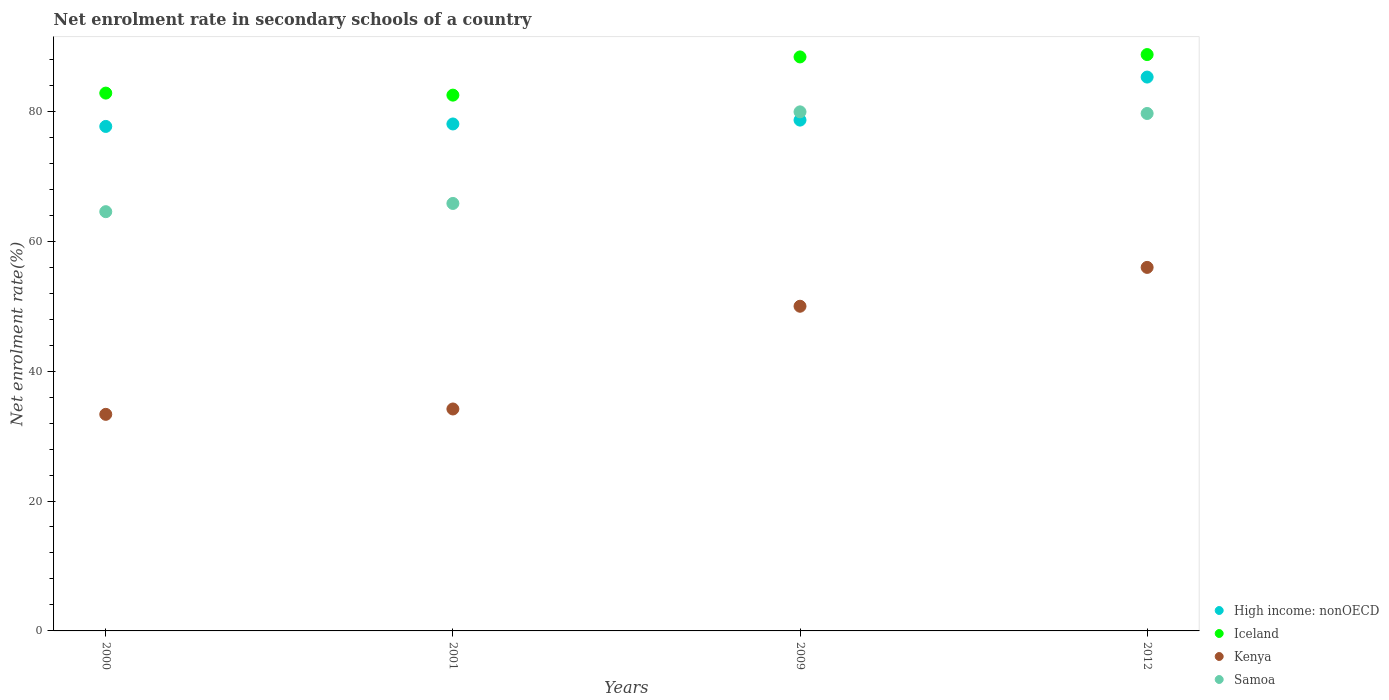What is the net enrolment rate in secondary schools in Iceland in 2000?
Provide a short and direct response. 82.8. Across all years, what is the maximum net enrolment rate in secondary schools in High income: nonOECD?
Make the answer very short. 85.27. Across all years, what is the minimum net enrolment rate in secondary schools in Iceland?
Your answer should be compact. 82.49. What is the total net enrolment rate in secondary schools in Kenya in the graph?
Your answer should be very brief. 173.46. What is the difference between the net enrolment rate in secondary schools in High income: nonOECD in 2009 and that in 2012?
Ensure brevity in your answer.  -6.63. What is the difference between the net enrolment rate in secondary schools in Iceland in 2000 and the net enrolment rate in secondary schools in Samoa in 2012?
Make the answer very short. 3.14. What is the average net enrolment rate in secondary schools in Kenya per year?
Offer a very short reply. 43.37. In the year 2009, what is the difference between the net enrolment rate in secondary schools in High income: nonOECD and net enrolment rate in secondary schools in Kenya?
Provide a short and direct response. 28.66. In how many years, is the net enrolment rate in secondary schools in Iceland greater than 48 %?
Keep it short and to the point. 4. What is the ratio of the net enrolment rate in secondary schools in High income: nonOECD in 2000 to that in 2012?
Your response must be concise. 0.91. Is the difference between the net enrolment rate in secondary schools in High income: nonOECD in 2001 and 2009 greater than the difference between the net enrolment rate in secondary schools in Kenya in 2001 and 2009?
Offer a terse response. Yes. What is the difference between the highest and the second highest net enrolment rate in secondary schools in High income: nonOECD?
Keep it short and to the point. 6.63. What is the difference between the highest and the lowest net enrolment rate in secondary schools in High income: nonOECD?
Provide a succinct answer. 7.6. Is it the case that in every year, the sum of the net enrolment rate in secondary schools in High income: nonOECD and net enrolment rate in secondary schools in Kenya  is greater than the sum of net enrolment rate in secondary schools in Samoa and net enrolment rate in secondary schools in Iceland?
Provide a succinct answer. Yes. Is it the case that in every year, the sum of the net enrolment rate in secondary schools in Samoa and net enrolment rate in secondary schools in Kenya  is greater than the net enrolment rate in secondary schools in Iceland?
Provide a short and direct response. Yes. Does the net enrolment rate in secondary schools in High income: nonOECD monotonically increase over the years?
Provide a succinct answer. Yes. Is the net enrolment rate in secondary schools in Iceland strictly greater than the net enrolment rate in secondary schools in High income: nonOECD over the years?
Offer a terse response. Yes. Is the net enrolment rate in secondary schools in Samoa strictly less than the net enrolment rate in secondary schools in Kenya over the years?
Your answer should be compact. No. How many dotlines are there?
Your answer should be compact. 4. How many years are there in the graph?
Your answer should be compact. 4. Does the graph contain any zero values?
Your response must be concise. No. Where does the legend appear in the graph?
Your answer should be compact. Bottom right. How many legend labels are there?
Keep it short and to the point. 4. What is the title of the graph?
Your answer should be very brief. Net enrolment rate in secondary schools of a country. Does "Belarus" appear as one of the legend labels in the graph?
Your answer should be compact. No. What is the label or title of the X-axis?
Offer a terse response. Years. What is the label or title of the Y-axis?
Offer a very short reply. Net enrolment rate(%). What is the Net enrolment rate(%) in High income: nonOECD in 2000?
Offer a very short reply. 77.67. What is the Net enrolment rate(%) in Iceland in 2000?
Your response must be concise. 82.8. What is the Net enrolment rate(%) of Kenya in 2000?
Ensure brevity in your answer.  33.34. What is the Net enrolment rate(%) in Samoa in 2000?
Keep it short and to the point. 64.54. What is the Net enrolment rate(%) of High income: nonOECD in 2001?
Offer a terse response. 78.05. What is the Net enrolment rate(%) in Iceland in 2001?
Ensure brevity in your answer.  82.49. What is the Net enrolment rate(%) of Kenya in 2001?
Offer a terse response. 34.17. What is the Net enrolment rate(%) of Samoa in 2001?
Your answer should be compact. 65.81. What is the Net enrolment rate(%) in High income: nonOECD in 2009?
Keep it short and to the point. 78.64. What is the Net enrolment rate(%) of Iceland in 2009?
Provide a short and direct response. 88.37. What is the Net enrolment rate(%) of Kenya in 2009?
Your answer should be compact. 49.98. What is the Net enrolment rate(%) of Samoa in 2009?
Provide a short and direct response. 79.91. What is the Net enrolment rate(%) in High income: nonOECD in 2012?
Provide a succinct answer. 85.27. What is the Net enrolment rate(%) of Iceland in 2012?
Ensure brevity in your answer.  88.73. What is the Net enrolment rate(%) of Kenya in 2012?
Provide a short and direct response. 55.97. What is the Net enrolment rate(%) of Samoa in 2012?
Ensure brevity in your answer.  79.66. Across all years, what is the maximum Net enrolment rate(%) in High income: nonOECD?
Make the answer very short. 85.27. Across all years, what is the maximum Net enrolment rate(%) of Iceland?
Offer a very short reply. 88.73. Across all years, what is the maximum Net enrolment rate(%) in Kenya?
Offer a terse response. 55.97. Across all years, what is the maximum Net enrolment rate(%) of Samoa?
Your response must be concise. 79.91. Across all years, what is the minimum Net enrolment rate(%) in High income: nonOECD?
Keep it short and to the point. 77.67. Across all years, what is the minimum Net enrolment rate(%) of Iceland?
Provide a succinct answer. 82.49. Across all years, what is the minimum Net enrolment rate(%) in Kenya?
Give a very brief answer. 33.34. Across all years, what is the minimum Net enrolment rate(%) of Samoa?
Make the answer very short. 64.54. What is the total Net enrolment rate(%) of High income: nonOECD in the graph?
Provide a succinct answer. 319.62. What is the total Net enrolment rate(%) of Iceland in the graph?
Give a very brief answer. 342.38. What is the total Net enrolment rate(%) of Kenya in the graph?
Provide a succinct answer. 173.46. What is the total Net enrolment rate(%) in Samoa in the graph?
Make the answer very short. 289.93. What is the difference between the Net enrolment rate(%) in High income: nonOECD in 2000 and that in 2001?
Provide a succinct answer. -0.38. What is the difference between the Net enrolment rate(%) in Iceland in 2000 and that in 2001?
Your answer should be compact. 0.31. What is the difference between the Net enrolment rate(%) in Kenya in 2000 and that in 2001?
Offer a very short reply. -0.83. What is the difference between the Net enrolment rate(%) in Samoa in 2000 and that in 2001?
Provide a short and direct response. -1.27. What is the difference between the Net enrolment rate(%) of High income: nonOECD in 2000 and that in 2009?
Your answer should be very brief. -0.97. What is the difference between the Net enrolment rate(%) of Iceland in 2000 and that in 2009?
Make the answer very short. -5.57. What is the difference between the Net enrolment rate(%) in Kenya in 2000 and that in 2009?
Your answer should be very brief. -16.64. What is the difference between the Net enrolment rate(%) of Samoa in 2000 and that in 2009?
Your response must be concise. -15.37. What is the difference between the Net enrolment rate(%) of High income: nonOECD in 2000 and that in 2012?
Make the answer very short. -7.6. What is the difference between the Net enrolment rate(%) of Iceland in 2000 and that in 2012?
Make the answer very short. -5.93. What is the difference between the Net enrolment rate(%) of Kenya in 2000 and that in 2012?
Your answer should be very brief. -22.62. What is the difference between the Net enrolment rate(%) of Samoa in 2000 and that in 2012?
Provide a short and direct response. -15.12. What is the difference between the Net enrolment rate(%) of High income: nonOECD in 2001 and that in 2009?
Your answer should be compact. -0.59. What is the difference between the Net enrolment rate(%) in Iceland in 2001 and that in 2009?
Provide a succinct answer. -5.88. What is the difference between the Net enrolment rate(%) of Kenya in 2001 and that in 2009?
Provide a short and direct response. -15.82. What is the difference between the Net enrolment rate(%) in Samoa in 2001 and that in 2009?
Offer a very short reply. -14.1. What is the difference between the Net enrolment rate(%) in High income: nonOECD in 2001 and that in 2012?
Provide a short and direct response. -7.22. What is the difference between the Net enrolment rate(%) of Iceland in 2001 and that in 2012?
Your answer should be very brief. -6.25. What is the difference between the Net enrolment rate(%) of Kenya in 2001 and that in 2012?
Give a very brief answer. -21.8. What is the difference between the Net enrolment rate(%) in Samoa in 2001 and that in 2012?
Your answer should be compact. -13.85. What is the difference between the Net enrolment rate(%) of High income: nonOECD in 2009 and that in 2012?
Provide a succinct answer. -6.63. What is the difference between the Net enrolment rate(%) in Iceland in 2009 and that in 2012?
Offer a terse response. -0.36. What is the difference between the Net enrolment rate(%) of Kenya in 2009 and that in 2012?
Your answer should be compact. -5.98. What is the difference between the Net enrolment rate(%) in Samoa in 2009 and that in 2012?
Ensure brevity in your answer.  0.25. What is the difference between the Net enrolment rate(%) of High income: nonOECD in 2000 and the Net enrolment rate(%) of Iceland in 2001?
Keep it short and to the point. -4.82. What is the difference between the Net enrolment rate(%) of High income: nonOECD in 2000 and the Net enrolment rate(%) of Kenya in 2001?
Offer a very short reply. 43.5. What is the difference between the Net enrolment rate(%) in High income: nonOECD in 2000 and the Net enrolment rate(%) in Samoa in 2001?
Provide a short and direct response. 11.86. What is the difference between the Net enrolment rate(%) of Iceland in 2000 and the Net enrolment rate(%) of Kenya in 2001?
Your answer should be compact. 48.63. What is the difference between the Net enrolment rate(%) of Iceland in 2000 and the Net enrolment rate(%) of Samoa in 2001?
Provide a short and direct response. 16.99. What is the difference between the Net enrolment rate(%) of Kenya in 2000 and the Net enrolment rate(%) of Samoa in 2001?
Your answer should be compact. -32.47. What is the difference between the Net enrolment rate(%) of High income: nonOECD in 2000 and the Net enrolment rate(%) of Iceland in 2009?
Your answer should be compact. -10.7. What is the difference between the Net enrolment rate(%) of High income: nonOECD in 2000 and the Net enrolment rate(%) of Kenya in 2009?
Make the answer very short. 27.68. What is the difference between the Net enrolment rate(%) in High income: nonOECD in 2000 and the Net enrolment rate(%) in Samoa in 2009?
Offer a very short reply. -2.24. What is the difference between the Net enrolment rate(%) of Iceland in 2000 and the Net enrolment rate(%) of Kenya in 2009?
Offer a very short reply. 32.81. What is the difference between the Net enrolment rate(%) in Iceland in 2000 and the Net enrolment rate(%) in Samoa in 2009?
Keep it short and to the point. 2.89. What is the difference between the Net enrolment rate(%) of Kenya in 2000 and the Net enrolment rate(%) of Samoa in 2009?
Your answer should be compact. -46.57. What is the difference between the Net enrolment rate(%) of High income: nonOECD in 2000 and the Net enrolment rate(%) of Iceland in 2012?
Provide a short and direct response. -11.06. What is the difference between the Net enrolment rate(%) of High income: nonOECD in 2000 and the Net enrolment rate(%) of Kenya in 2012?
Provide a short and direct response. 21.7. What is the difference between the Net enrolment rate(%) in High income: nonOECD in 2000 and the Net enrolment rate(%) in Samoa in 2012?
Your response must be concise. -1.99. What is the difference between the Net enrolment rate(%) in Iceland in 2000 and the Net enrolment rate(%) in Kenya in 2012?
Make the answer very short. 26.83. What is the difference between the Net enrolment rate(%) in Iceland in 2000 and the Net enrolment rate(%) in Samoa in 2012?
Your answer should be very brief. 3.14. What is the difference between the Net enrolment rate(%) in Kenya in 2000 and the Net enrolment rate(%) in Samoa in 2012?
Provide a short and direct response. -46.32. What is the difference between the Net enrolment rate(%) of High income: nonOECD in 2001 and the Net enrolment rate(%) of Iceland in 2009?
Offer a terse response. -10.32. What is the difference between the Net enrolment rate(%) in High income: nonOECD in 2001 and the Net enrolment rate(%) in Kenya in 2009?
Your answer should be compact. 28.06. What is the difference between the Net enrolment rate(%) in High income: nonOECD in 2001 and the Net enrolment rate(%) in Samoa in 2009?
Offer a terse response. -1.86. What is the difference between the Net enrolment rate(%) of Iceland in 2001 and the Net enrolment rate(%) of Kenya in 2009?
Offer a very short reply. 32.5. What is the difference between the Net enrolment rate(%) in Iceland in 2001 and the Net enrolment rate(%) in Samoa in 2009?
Give a very brief answer. 2.57. What is the difference between the Net enrolment rate(%) in Kenya in 2001 and the Net enrolment rate(%) in Samoa in 2009?
Give a very brief answer. -45.74. What is the difference between the Net enrolment rate(%) of High income: nonOECD in 2001 and the Net enrolment rate(%) of Iceland in 2012?
Offer a very short reply. -10.68. What is the difference between the Net enrolment rate(%) of High income: nonOECD in 2001 and the Net enrolment rate(%) of Kenya in 2012?
Offer a very short reply. 22.08. What is the difference between the Net enrolment rate(%) of High income: nonOECD in 2001 and the Net enrolment rate(%) of Samoa in 2012?
Offer a terse response. -1.61. What is the difference between the Net enrolment rate(%) in Iceland in 2001 and the Net enrolment rate(%) in Kenya in 2012?
Provide a succinct answer. 26.52. What is the difference between the Net enrolment rate(%) in Iceland in 2001 and the Net enrolment rate(%) in Samoa in 2012?
Your answer should be very brief. 2.82. What is the difference between the Net enrolment rate(%) of Kenya in 2001 and the Net enrolment rate(%) of Samoa in 2012?
Offer a terse response. -45.49. What is the difference between the Net enrolment rate(%) in High income: nonOECD in 2009 and the Net enrolment rate(%) in Iceland in 2012?
Ensure brevity in your answer.  -10.09. What is the difference between the Net enrolment rate(%) of High income: nonOECD in 2009 and the Net enrolment rate(%) of Kenya in 2012?
Make the answer very short. 22.68. What is the difference between the Net enrolment rate(%) of High income: nonOECD in 2009 and the Net enrolment rate(%) of Samoa in 2012?
Keep it short and to the point. -1.02. What is the difference between the Net enrolment rate(%) of Iceland in 2009 and the Net enrolment rate(%) of Kenya in 2012?
Your answer should be very brief. 32.4. What is the difference between the Net enrolment rate(%) of Iceland in 2009 and the Net enrolment rate(%) of Samoa in 2012?
Your response must be concise. 8.71. What is the difference between the Net enrolment rate(%) of Kenya in 2009 and the Net enrolment rate(%) of Samoa in 2012?
Provide a succinct answer. -29.68. What is the average Net enrolment rate(%) in High income: nonOECD per year?
Keep it short and to the point. 79.91. What is the average Net enrolment rate(%) in Iceland per year?
Your answer should be compact. 85.6. What is the average Net enrolment rate(%) of Kenya per year?
Provide a short and direct response. 43.37. What is the average Net enrolment rate(%) of Samoa per year?
Ensure brevity in your answer.  72.48. In the year 2000, what is the difference between the Net enrolment rate(%) in High income: nonOECD and Net enrolment rate(%) in Iceland?
Your answer should be very brief. -5.13. In the year 2000, what is the difference between the Net enrolment rate(%) in High income: nonOECD and Net enrolment rate(%) in Kenya?
Provide a short and direct response. 44.33. In the year 2000, what is the difference between the Net enrolment rate(%) in High income: nonOECD and Net enrolment rate(%) in Samoa?
Your response must be concise. 13.12. In the year 2000, what is the difference between the Net enrolment rate(%) of Iceland and Net enrolment rate(%) of Kenya?
Offer a terse response. 49.46. In the year 2000, what is the difference between the Net enrolment rate(%) of Iceland and Net enrolment rate(%) of Samoa?
Give a very brief answer. 18.26. In the year 2000, what is the difference between the Net enrolment rate(%) in Kenya and Net enrolment rate(%) in Samoa?
Your response must be concise. -31.2. In the year 2001, what is the difference between the Net enrolment rate(%) in High income: nonOECD and Net enrolment rate(%) in Iceland?
Ensure brevity in your answer.  -4.44. In the year 2001, what is the difference between the Net enrolment rate(%) in High income: nonOECD and Net enrolment rate(%) in Kenya?
Your answer should be very brief. 43.88. In the year 2001, what is the difference between the Net enrolment rate(%) in High income: nonOECD and Net enrolment rate(%) in Samoa?
Provide a short and direct response. 12.24. In the year 2001, what is the difference between the Net enrolment rate(%) of Iceland and Net enrolment rate(%) of Kenya?
Your answer should be very brief. 48.32. In the year 2001, what is the difference between the Net enrolment rate(%) in Iceland and Net enrolment rate(%) in Samoa?
Ensure brevity in your answer.  16.67. In the year 2001, what is the difference between the Net enrolment rate(%) in Kenya and Net enrolment rate(%) in Samoa?
Your answer should be compact. -31.64. In the year 2009, what is the difference between the Net enrolment rate(%) in High income: nonOECD and Net enrolment rate(%) in Iceland?
Ensure brevity in your answer.  -9.73. In the year 2009, what is the difference between the Net enrolment rate(%) in High income: nonOECD and Net enrolment rate(%) in Kenya?
Offer a terse response. 28.66. In the year 2009, what is the difference between the Net enrolment rate(%) of High income: nonOECD and Net enrolment rate(%) of Samoa?
Your answer should be very brief. -1.27. In the year 2009, what is the difference between the Net enrolment rate(%) in Iceland and Net enrolment rate(%) in Kenya?
Keep it short and to the point. 38.38. In the year 2009, what is the difference between the Net enrolment rate(%) in Iceland and Net enrolment rate(%) in Samoa?
Ensure brevity in your answer.  8.46. In the year 2009, what is the difference between the Net enrolment rate(%) in Kenya and Net enrolment rate(%) in Samoa?
Provide a succinct answer. -29.93. In the year 2012, what is the difference between the Net enrolment rate(%) in High income: nonOECD and Net enrolment rate(%) in Iceland?
Give a very brief answer. -3.46. In the year 2012, what is the difference between the Net enrolment rate(%) in High income: nonOECD and Net enrolment rate(%) in Kenya?
Offer a very short reply. 29.3. In the year 2012, what is the difference between the Net enrolment rate(%) in High income: nonOECD and Net enrolment rate(%) in Samoa?
Ensure brevity in your answer.  5.61. In the year 2012, what is the difference between the Net enrolment rate(%) of Iceland and Net enrolment rate(%) of Kenya?
Your answer should be compact. 32.77. In the year 2012, what is the difference between the Net enrolment rate(%) in Iceland and Net enrolment rate(%) in Samoa?
Make the answer very short. 9.07. In the year 2012, what is the difference between the Net enrolment rate(%) of Kenya and Net enrolment rate(%) of Samoa?
Offer a very short reply. -23.7. What is the ratio of the Net enrolment rate(%) in High income: nonOECD in 2000 to that in 2001?
Offer a terse response. 1. What is the ratio of the Net enrolment rate(%) in Iceland in 2000 to that in 2001?
Your answer should be compact. 1. What is the ratio of the Net enrolment rate(%) of Kenya in 2000 to that in 2001?
Provide a succinct answer. 0.98. What is the ratio of the Net enrolment rate(%) in Samoa in 2000 to that in 2001?
Your response must be concise. 0.98. What is the ratio of the Net enrolment rate(%) in High income: nonOECD in 2000 to that in 2009?
Your response must be concise. 0.99. What is the ratio of the Net enrolment rate(%) in Iceland in 2000 to that in 2009?
Your answer should be compact. 0.94. What is the ratio of the Net enrolment rate(%) of Kenya in 2000 to that in 2009?
Make the answer very short. 0.67. What is the ratio of the Net enrolment rate(%) of Samoa in 2000 to that in 2009?
Provide a succinct answer. 0.81. What is the ratio of the Net enrolment rate(%) in High income: nonOECD in 2000 to that in 2012?
Offer a very short reply. 0.91. What is the ratio of the Net enrolment rate(%) of Iceland in 2000 to that in 2012?
Keep it short and to the point. 0.93. What is the ratio of the Net enrolment rate(%) of Kenya in 2000 to that in 2012?
Keep it short and to the point. 0.6. What is the ratio of the Net enrolment rate(%) of Samoa in 2000 to that in 2012?
Make the answer very short. 0.81. What is the ratio of the Net enrolment rate(%) of Iceland in 2001 to that in 2009?
Offer a terse response. 0.93. What is the ratio of the Net enrolment rate(%) in Kenya in 2001 to that in 2009?
Offer a terse response. 0.68. What is the ratio of the Net enrolment rate(%) in Samoa in 2001 to that in 2009?
Provide a short and direct response. 0.82. What is the ratio of the Net enrolment rate(%) in High income: nonOECD in 2001 to that in 2012?
Provide a succinct answer. 0.92. What is the ratio of the Net enrolment rate(%) in Iceland in 2001 to that in 2012?
Your response must be concise. 0.93. What is the ratio of the Net enrolment rate(%) in Kenya in 2001 to that in 2012?
Provide a short and direct response. 0.61. What is the ratio of the Net enrolment rate(%) of Samoa in 2001 to that in 2012?
Your response must be concise. 0.83. What is the ratio of the Net enrolment rate(%) of High income: nonOECD in 2009 to that in 2012?
Provide a succinct answer. 0.92. What is the ratio of the Net enrolment rate(%) of Iceland in 2009 to that in 2012?
Your answer should be compact. 1. What is the ratio of the Net enrolment rate(%) of Kenya in 2009 to that in 2012?
Ensure brevity in your answer.  0.89. What is the ratio of the Net enrolment rate(%) in Samoa in 2009 to that in 2012?
Your answer should be compact. 1. What is the difference between the highest and the second highest Net enrolment rate(%) in High income: nonOECD?
Your answer should be compact. 6.63. What is the difference between the highest and the second highest Net enrolment rate(%) of Iceland?
Give a very brief answer. 0.36. What is the difference between the highest and the second highest Net enrolment rate(%) of Kenya?
Offer a very short reply. 5.98. What is the difference between the highest and the second highest Net enrolment rate(%) in Samoa?
Provide a short and direct response. 0.25. What is the difference between the highest and the lowest Net enrolment rate(%) in High income: nonOECD?
Your response must be concise. 7.6. What is the difference between the highest and the lowest Net enrolment rate(%) in Iceland?
Ensure brevity in your answer.  6.25. What is the difference between the highest and the lowest Net enrolment rate(%) in Kenya?
Provide a succinct answer. 22.62. What is the difference between the highest and the lowest Net enrolment rate(%) in Samoa?
Give a very brief answer. 15.37. 